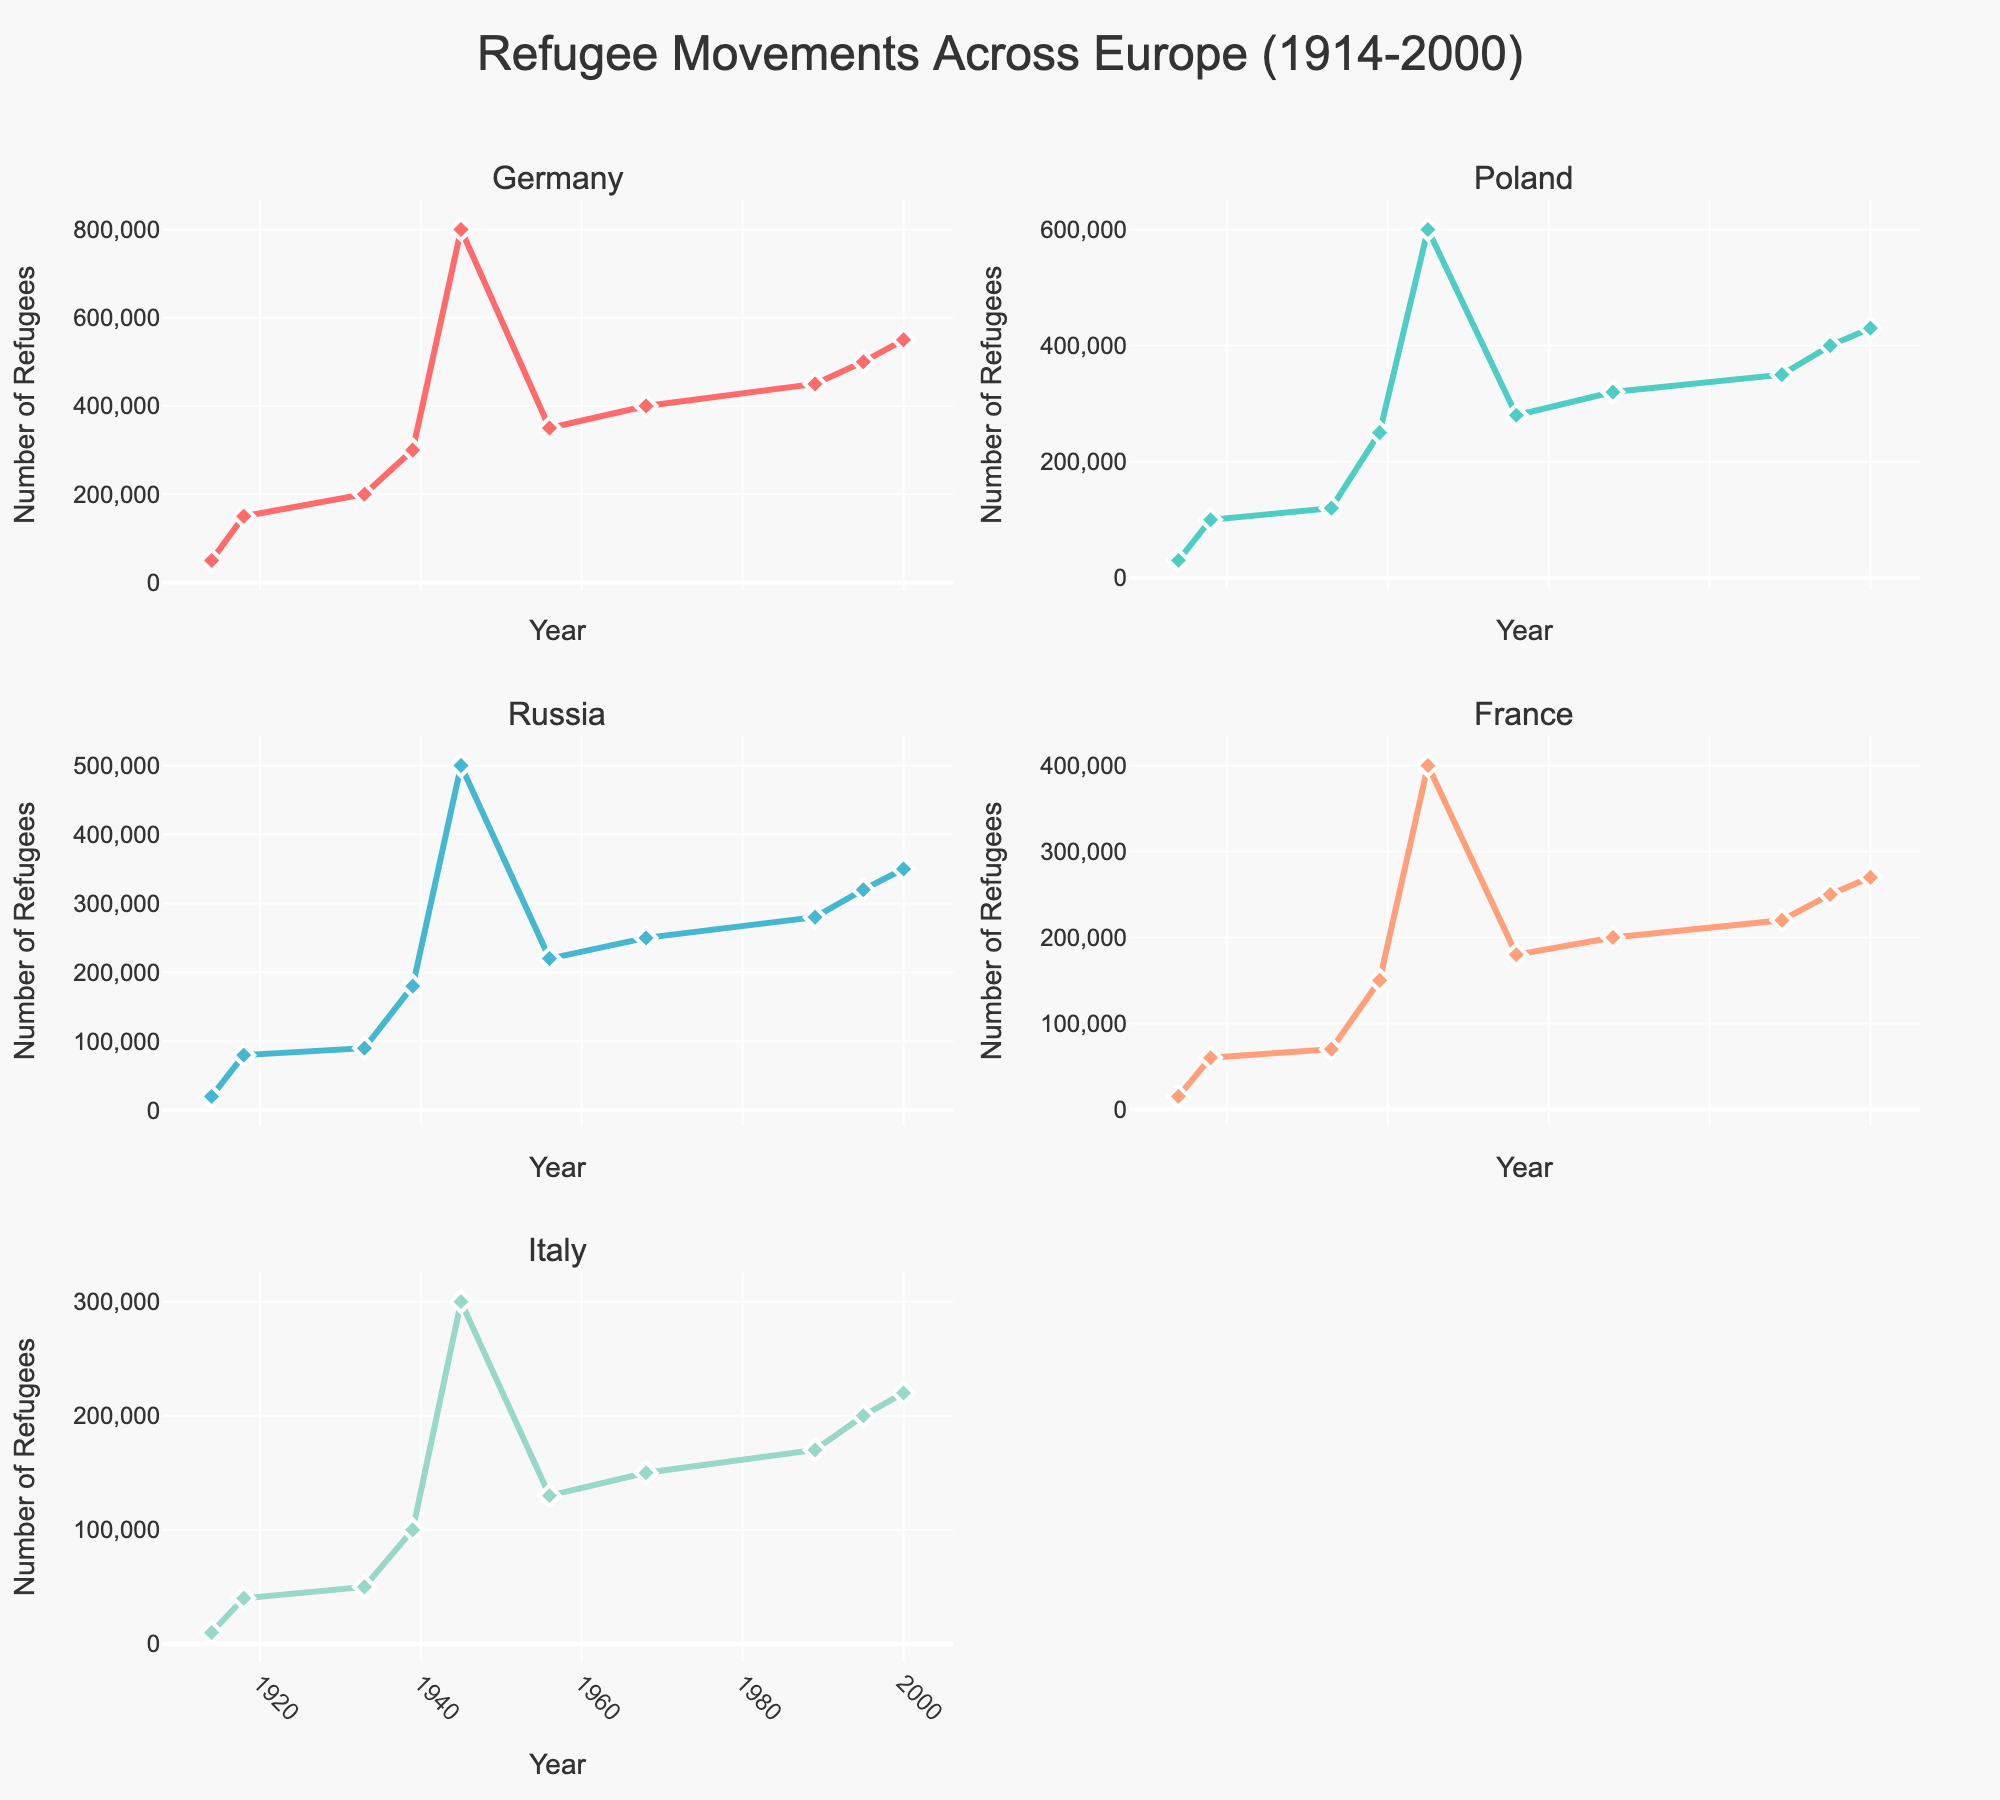What's the title of the pie chart? The title can be found at the top of the pie chart, it summarizes the plot's content: "Library Program Attendance".
Answer: Library Program Attendance How many different types of programs are displayed in the pie chart? Count the number of distinct program types listed around the pie chart.
Answer: 7 Which program has the highest attendance percentage? By looking at the pie chart, the segment with the largest slice will have the highest attendance percentage, labeled with its program type and percent.
Answer: Story Time What is the attendance percentage for Digital Literacy Classes? Locate the segment labeled "Digital Literacy Classes" and note its percentage value.
Answer: 18% What is the combined attendance percentage of Adult Education and Community Events? Identify both segments (Adult Education and Community Events) and add their attendance percentages: 22% + 15%.
Answer: 37% Which program has a smaller attendance percentage, Teen Programs or Author Talks? Compare the two segments labeled "Teen Programs" and "Author Talks". The one with the lower percentage is the smaller attendance percentage.
Answer: Teen Programs Is the percentage for Story Time more than the combined total of Book Clubs and Author Talks? Sum the percentages for Book Clubs (8%) and Author Talks (5%) and compare it with the percentage for Story Time (28%). 13% which is Book Clubs + Author Talks is less than 28%.
Answer: Yes What is the average attendance percentage of all the programs? Sum up the percentages of all programs and then divide by the number of programs: (28 + 22 + 18 + 15 + 8 + 5 + 4) / 7.
Answer: 14.29% Which programs' segments are pulled out from the pie chart? Only the segment with the highest value is pulled out. Look for the one that is slightly separated from the rest.
Answer: Story Time 